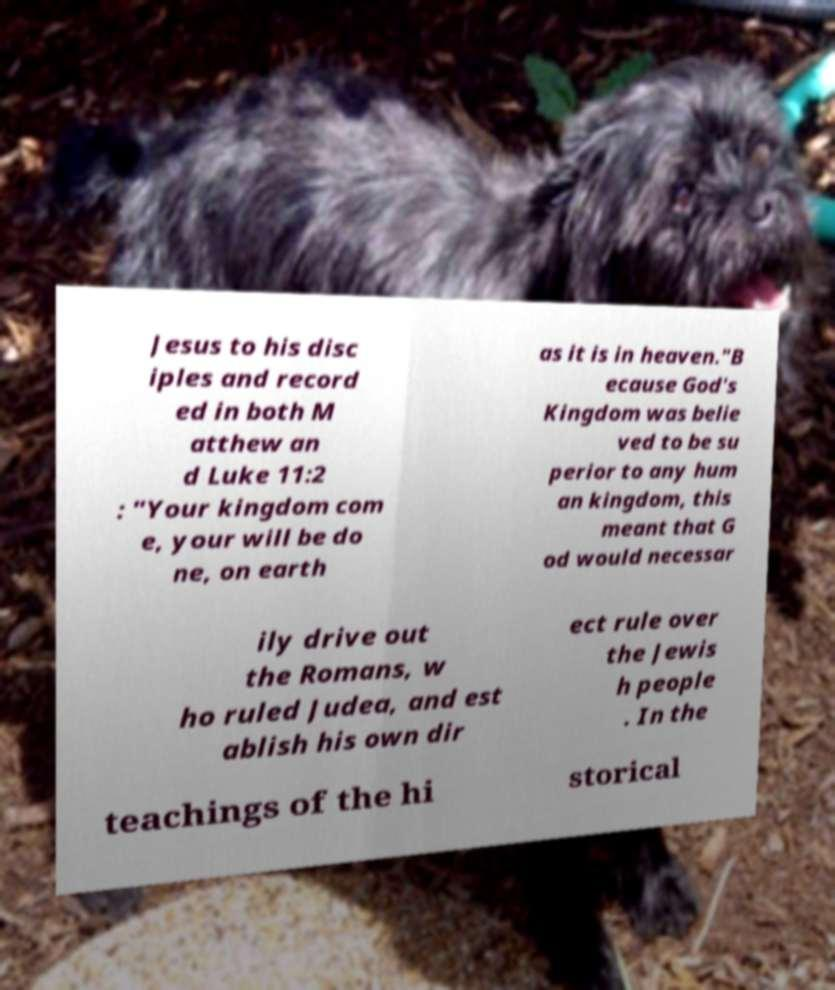What messages or text are displayed in this image? I need them in a readable, typed format. Jesus to his disc iples and record ed in both M atthew an d Luke 11:2 : "Your kingdom com e, your will be do ne, on earth as it is in heaven."B ecause God's Kingdom was belie ved to be su perior to any hum an kingdom, this meant that G od would necessar ily drive out the Romans, w ho ruled Judea, and est ablish his own dir ect rule over the Jewis h people . In the teachings of the hi storical 